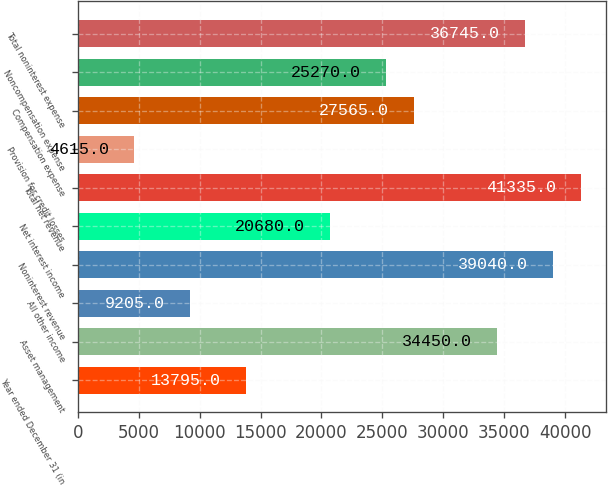Convert chart. <chart><loc_0><loc_0><loc_500><loc_500><bar_chart><fcel>Year ended December 31 (in<fcel>Asset management<fcel>All other income<fcel>Noninterest revenue<fcel>Net interest income<fcel>Total net revenue<fcel>Provision for credit losses<fcel>Compensation expense<fcel>Noncompensation expense<fcel>Total noninterest expense<nl><fcel>13795<fcel>34450<fcel>9205<fcel>39040<fcel>20680<fcel>41335<fcel>4615<fcel>27565<fcel>25270<fcel>36745<nl></chart> 